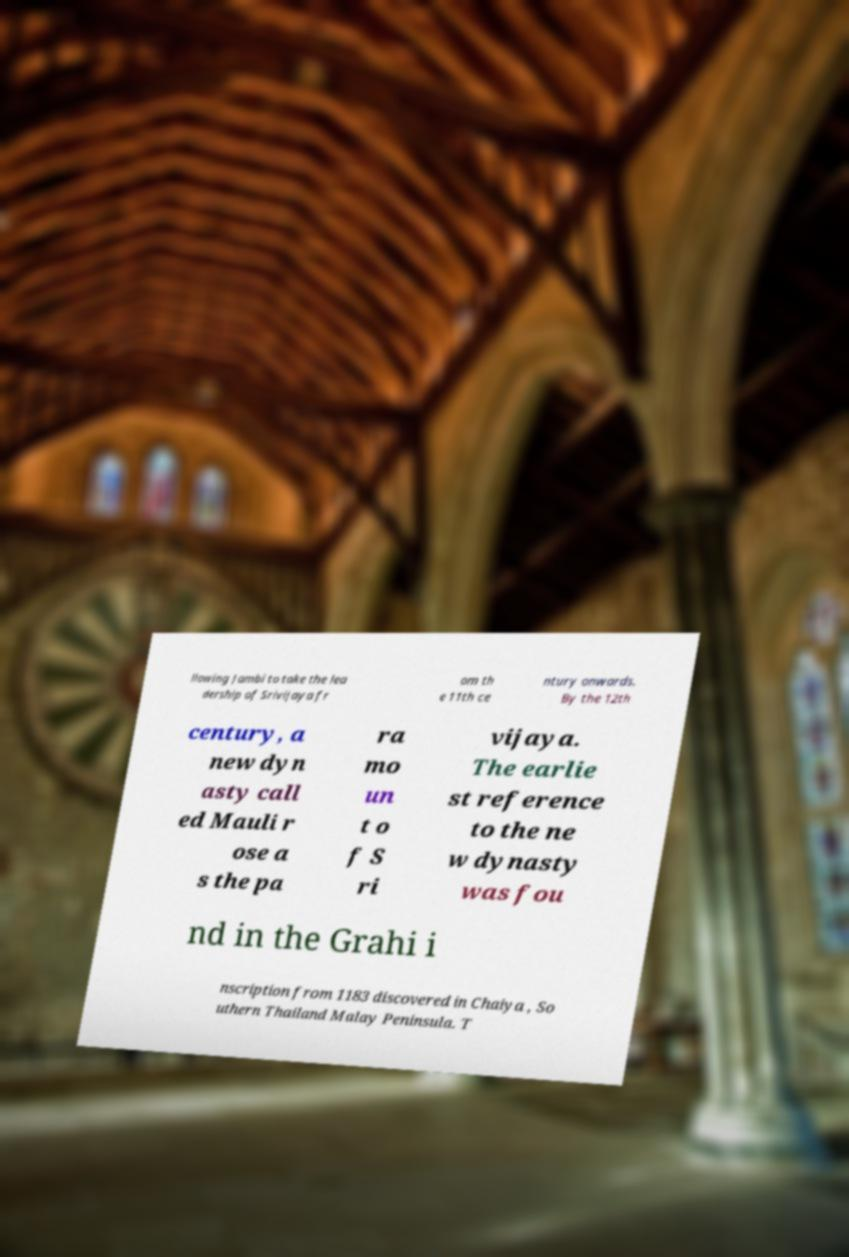Could you extract and type out the text from this image? llowing Jambi to take the lea dership of Srivijaya fr om th e 11th ce ntury onwards. By the 12th century, a new dyn asty call ed Mauli r ose a s the pa ra mo un t o f S ri vijaya. The earlie st reference to the ne w dynasty was fou nd in the Grahi i nscription from 1183 discovered in Chaiya , So uthern Thailand Malay Peninsula. T 